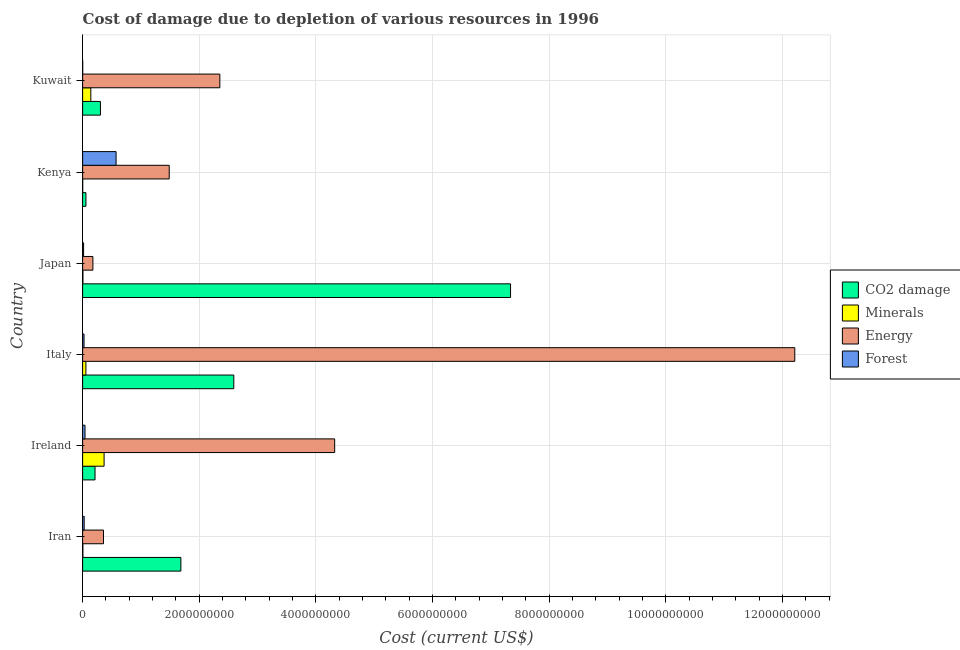How many different coloured bars are there?
Your answer should be compact. 4. How many groups of bars are there?
Offer a very short reply. 6. Are the number of bars per tick equal to the number of legend labels?
Keep it short and to the point. Yes. Are the number of bars on each tick of the Y-axis equal?
Give a very brief answer. Yes. How many bars are there on the 5th tick from the bottom?
Provide a succinct answer. 4. What is the label of the 2nd group of bars from the top?
Your response must be concise. Kenya. In how many cases, is the number of bars for a given country not equal to the number of legend labels?
Offer a very short reply. 0. What is the cost of damage due to depletion of minerals in Italy?
Provide a short and direct response. 5.60e+07. Across all countries, what is the maximum cost of damage due to depletion of forests?
Offer a very short reply. 5.74e+08. Across all countries, what is the minimum cost of damage due to depletion of energy?
Keep it short and to the point. 1.76e+08. In which country was the cost of damage due to depletion of minerals minimum?
Provide a short and direct response. Kenya. What is the total cost of damage due to depletion of forests in the graph?
Ensure brevity in your answer.  6.82e+08. What is the difference between the cost of damage due to depletion of energy in Iran and that in Ireland?
Your answer should be very brief. -3.96e+09. What is the difference between the cost of damage due to depletion of coal in Iran and the cost of damage due to depletion of minerals in Ireland?
Provide a short and direct response. 1.32e+09. What is the average cost of damage due to depletion of energy per country?
Your response must be concise. 3.48e+09. What is the difference between the cost of damage due to depletion of minerals and cost of damage due to depletion of energy in Japan?
Your response must be concise. -1.71e+08. What is the ratio of the cost of damage due to depletion of minerals in Japan to that in Kenya?
Provide a succinct answer. 3.73. Is the cost of damage due to depletion of forests in Ireland less than that in Japan?
Make the answer very short. No. What is the difference between the highest and the second highest cost of damage due to depletion of forests?
Ensure brevity in your answer.  5.33e+08. What is the difference between the highest and the lowest cost of damage due to depletion of energy?
Make the answer very short. 1.20e+1. Is it the case that in every country, the sum of the cost of damage due to depletion of coal and cost of damage due to depletion of forests is greater than the sum of cost of damage due to depletion of minerals and cost of damage due to depletion of energy?
Give a very brief answer. No. What does the 1st bar from the top in Kenya represents?
Make the answer very short. Forest. What does the 4th bar from the bottom in Kenya represents?
Provide a succinct answer. Forest. Is it the case that in every country, the sum of the cost of damage due to depletion of coal and cost of damage due to depletion of minerals is greater than the cost of damage due to depletion of energy?
Give a very brief answer. No. How many bars are there?
Offer a terse response. 24. What is the difference between two consecutive major ticks on the X-axis?
Offer a very short reply. 2.00e+09. Does the graph contain any zero values?
Keep it short and to the point. No. Where does the legend appear in the graph?
Ensure brevity in your answer.  Center right. How are the legend labels stacked?
Your answer should be compact. Vertical. What is the title of the graph?
Your response must be concise. Cost of damage due to depletion of various resources in 1996 . Does "Primary" appear as one of the legend labels in the graph?
Your answer should be compact. No. What is the label or title of the X-axis?
Your answer should be compact. Cost (current US$). What is the label or title of the Y-axis?
Provide a succinct answer. Country. What is the Cost (current US$) in CO2 damage in Iran?
Your response must be concise. 1.68e+09. What is the Cost (current US$) in Minerals in Iran?
Ensure brevity in your answer.  3.78e+06. What is the Cost (current US$) in Energy in Iran?
Provide a succinct answer. 3.58e+08. What is the Cost (current US$) of Forest in Iran?
Give a very brief answer. 2.68e+07. What is the Cost (current US$) in CO2 damage in Ireland?
Ensure brevity in your answer.  2.13e+08. What is the Cost (current US$) in Minerals in Ireland?
Your response must be concise. 3.68e+08. What is the Cost (current US$) in Energy in Ireland?
Your answer should be very brief. 4.32e+09. What is the Cost (current US$) of Forest in Ireland?
Provide a succinct answer. 4.08e+07. What is the Cost (current US$) in CO2 damage in Italy?
Your answer should be compact. 2.59e+09. What is the Cost (current US$) in Minerals in Italy?
Your answer should be very brief. 5.60e+07. What is the Cost (current US$) of Energy in Italy?
Ensure brevity in your answer.  1.22e+1. What is the Cost (current US$) in Forest in Italy?
Provide a short and direct response. 2.40e+07. What is the Cost (current US$) of CO2 damage in Japan?
Your answer should be compact. 7.34e+09. What is the Cost (current US$) in Minerals in Japan?
Your answer should be very brief. 4.88e+06. What is the Cost (current US$) in Energy in Japan?
Keep it short and to the point. 1.76e+08. What is the Cost (current US$) of Forest in Japan?
Provide a short and direct response. 1.65e+07. What is the Cost (current US$) of CO2 damage in Kenya?
Your response must be concise. 5.68e+07. What is the Cost (current US$) of Minerals in Kenya?
Provide a short and direct response. 1.31e+06. What is the Cost (current US$) in Energy in Kenya?
Your answer should be very brief. 1.49e+09. What is the Cost (current US$) in Forest in Kenya?
Your answer should be very brief. 5.74e+08. What is the Cost (current US$) of CO2 damage in Kuwait?
Your answer should be very brief. 3.05e+08. What is the Cost (current US$) of Minerals in Kuwait?
Provide a succinct answer. 1.40e+08. What is the Cost (current US$) of Energy in Kuwait?
Your answer should be compact. 2.35e+09. What is the Cost (current US$) in Forest in Kuwait?
Make the answer very short. 6.19e+05. Across all countries, what is the maximum Cost (current US$) in CO2 damage?
Your answer should be compact. 7.34e+09. Across all countries, what is the maximum Cost (current US$) of Minerals?
Offer a terse response. 3.68e+08. Across all countries, what is the maximum Cost (current US$) of Energy?
Provide a succinct answer. 1.22e+1. Across all countries, what is the maximum Cost (current US$) of Forest?
Provide a short and direct response. 5.74e+08. Across all countries, what is the minimum Cost (current US$) in CO2 damage?
Give a very brief answer. 5.68e+07. Across all countries, what is the minimum Cost (current US$) of Minerals?
Ensure brevity in your answer.  1.31e+06. Across all countries, what is the minimum Cost (current US$) in Energy?
Ensure brevity in your answer.  1.76e+08. Across all countries, what is the minimum Cost (current US$) of Forest?
Provide a succinct answer. 6.19e+05. What is the total Cost (current US$) in CO2 damage in the graph?
Provide a succinct answer. 1.22e+1. What is the total Cost (current US$) in Minerals in the graph?
Offer a terse response. 5.74e+08. What is the total Cost (current US$) of Energy in the graph?
Your answer should be very brief. 2.09e+1. What is the total Cost (current US$) of Forest in the graph?
Provide a succinct answer. 6.82e+08. What is the difference between the Cost (current US$) of CO2 damage in Iran and that in Ireland?
Keep it short and to the point. 1.47e+09. What is the difference between the Cost (current US$) of Minerals in Iran and that in Ireland?
Offer a very short reply. -3.64e+08. What is the difference between the Cost (current US$) of Energy in Iran and that in Ireland?
Give a very brief answer. -3.96e+09. What is the difference between the Cost (current US$) in Forest in Iran and that in Ireland?
Ensure brevity in your answer.  -1.41e+07. What is the difference between the Cost (current US$) of CO2 damage in Iran and that in Italy?
Give a very brief answer. -9.08e+08. What is the difference between the Cost (current US$) in Minerals in Iran and that in Italy?
Give a very brief answer. -5.22e+07. What is the difference between the Cost (current US$) in Energy in Iran and that in Italy?
Ensure brevity in your answer.  -1.19e+1. What is the difference between the Cost (current US$) of Forest in Iran and that in Italy?
Your answer should be compact. 2.76e+06. What is the difference between the Cost (current US$) of CO2 damage in Iran and that in Japan?
Offer a very short reply. -5.65e+09. What is the difference between the Cost (current US$) of Minerals in Iran and that in Japan?
Your response must be concise. -1.10e+06. What is the difference between the Cost (current US$) of Energy in Iran and that in Japan?
Keep it short and to the point. 1.82e+08. What is the difference between the Cost (current US$) of Forest in Iran and that in Japan?
Your answer should be very brief. 1.03e+07. What is the difference between the Cost (current US$) in CO2 damage in Iran and that in Kenya?
Give a very brief answer. 1.63e+09. What is the difference between the Cost (current US$) in Minerals in Iran and that in Kenya?
Offer a very short reply. 2.47e+06. What is the difference between the Cost (current US$) of Energy in Iran and that in Kenya?
Ensure brevity in your answer.  -1.13e+09. What is the difference between the Cost (current US$) in Forest in Iran and that in Kenya?
Keep it short and to the point. -5.47e+08. What is the difference between the Cost (current US$) in CO2 damage in Iran and that in Kuwait?
Provide a succinct answer. 1.38e+09. What is the difference between the Cost (current US$) of Minerals in Iran and that in Kuwait?
Provide a short and direct response. -1.36e+08. What is the difference between the Cost (current US$) of Energy in Iran and that in Kuwait?
Provide a short and direct response. -2.00e+09. What is the difference between the Cost (current US$) of Forest in Iran and that in Kuwait?
Ensure brevity in your answer.  2.61e+07. What is the difference between the Cost (current US$) of CO2 damage in Ireland and that in Italy?
Keep it short and to the point. -2.38e+09. What is the difference between the Cost (current US$) in Minerals in Ireland and that in Italy?
Give a very brief answer. 3.12e+08. What is the difference between the Cost (current US$) in Energy in Ireland and that in Italy?
Give a very brief answer. -7.89e+09. What is the difference between the Cost (current US$) in Forest in Ireland and that in Italy?
Offer a very short reply. 1.68e+07. What is the difference between the Cost (current US$) of CO2 damage in Ireland and that in Japan?
Provide a succinct answer. -7.13e+09. What is the difference between the Cost (current US$) in Minerals in Ireland and that in Japan?
Offer a terse response. 3.63e+08. What is the difference between the Cost (current US$) in Energy in Ireland and that in Japan?
Offer a very short reply. 4.15e+09. What is the difference between the Cost (current US$) in Forest in Ireland and that in Japan?
Your response must be concise. 2.43e+07. What is the difference between the Cost (current US$) in CO2 damage in Ireland and that in Kenya?
Provide a succinct answer. 1.56e+08. What is the difference between the Cost (current US$) of Minerals in Ireland and that in Kenya?
Your response must be concise. 3.67e+08. What is the difference between the Cost (current US$) of Energy in Ireland and that in Kenya?
Provide a short and direct response. 2.84e+09. What is the difference between the Cost (current US$) in Forest in Ireland and that in Kenya?
Offer a very short reply. -5.33e+08. What is the difference between the Cost (current US$) in CO2 damage in Ireland and that in Kuwait?
Your answer should be very brief. -9.28e+07. What is the difference between the Cost (current US$) in Minerals in Ireland and that in Kuwait?
Offer a very short reply. 2.28e+08. What is the difference between the Cost (current US$) in Energy in Ireland and that in Kuwait?
Your answer should be very brief. 1.97e+09. What is the difference between the Cost (current US$) in Forest in Ireland and that in Kuwait?
Offer a very short reply. 4.02e+07. What is the difference between the Cost (current US$) of CO2 damage in Italy and that in Japan?
Your response must be concise. -4.75e+09. What is the difference between the Cost (current US$) in Minerals in Italy and that in Japan?
Your answer should be very brief. 5.11e+07. What is the difference between the Cost (current US$) in Energy in Italy and that in Japan?
Provide a short and direct response. 1.20e+1. What is the difference between the Cost (current US$) of Forest in Italy and that in Japan?
Offer a very short reply. 7.50e+06. What is the difference between the Cost (current US$) of CO2 damage in Italy and that in Kenya?
Offer a terse response. 2.54e+09. What is the difference between the Cost (current US$) in Minerals in Italy and that in Kenya?
Offer a terse response. 5.47e+07. What is the difference between the Cost (current US$) in Energy in Italy and that in Kenya?
Your answer should be very brief. 1.07e+1. What is the difference between the Cost (current US$) of Forest in Italy and that in Kenya?
Your answer should be very brief. -5.50e+08. What is the difference between the Cost (current US$) of CO2 damage in Italy and that in Kuwait?
Provide a short and direct response. 2.29e+09. What is the difference between the Cost (current US$) in Minerals in Italy and that in Kuwait?
Your answer should be compact. -8.43e+07. What is the difference between the Cost (current US$) in Energy in Italy and that in Kuwait?
Make the answer very short. 9.86e+09. What is the difference between the Cost (current US$) in Forest in Italy and that in Kuwait?
Keep it short and to the point. 2.34e+07. What is the difference between the Cost (current US$) in CO2 damage in Japan and that in Kenya?
Provide a short and direct response. 7.28e+09. What is the difference between the Cost (current US$) in Minerals in Japan and that in Kenya?
Provide a succinct answer. 3.57e+06. What is the difference between the Cost (current US$) of Energy in Japan and that in Kenya?
Your response must be concise. -1.31e+09. What is the difference between the Cost (current US$) of Forest in Japan and that in Kenya?
Give a very brief answer. -5.57e+08. What is the difference between the Cost (current US$) of CO2 damage in Japan and that in Kuwait?
Provide a succinct answer. 7.03e+09. What is the difference between the Cost (current US$) of Minerals in Japan and that in Kuwait?
Keep it short and to the point. -1.35e+08. What is the difference between the Cost (current US$) of Energy in Japan and that in Kuwait?
Your response must be concise. -2.18e+09. What is the difference between the Cost (current US$) in Forest in Japan and that in Kuwait?
Provide a succinct answer. 1.59e+07. What is the difference between the Cost (current US$) in CO2 damage in Kenya and that in Kuwait?
Give a very brief answer. -2.49e+08. What is the difference between the Cost (current US$) of Minerals in Kenya and that in Kuwait?
Offer a very short reply. -1.39e+08. What is the difference between the Cost (current US$) of Energy in Kenya and that in Kuwait?
Provide a succinct answer. -8.68e+08. What is the difference between the Cost (current US$) of Forest in Kenya and that in Kuwait?
Give a very brief answer. 5.73e+08. What is the difference between the Cost (current US$) of CO2 damage in Iran and the Cost (current US$) of Minerals in Ireland?
Your answer should be very brief. 1.32e+09. What is the difference between the Cost (current US$) in CO2 damage in Iran and the Cost (current US$) in Energy in Ireland?
Your response must be concise. -2.64e+09. What is the difference between the Cost (current US$) in CO2 damage in Iran and the Cost (current US$) in Forest in Ireland?
Your response must be concise. 1.64e+09. What is the difference between the Cost (current US$) of Minerals in Iran and the Cost (current US$) of Energy in Ireland?
Provide a succinct answer. -4.32e+09. What is the difference between the Cost (current US$) in Minerals in Iran and the Cost (current US$) in Forest in Ireland?
Offer a terse response. -3.70e+07. What is the difference between the Cost (current US$) in Energy in Iran and the Cost (current US$) in Forest in Ireland?
Offer a very short reply. 3.17e+08. What is the difference between the Cost (current US$) of CO2 damage in Iran and the Cost (current US$) of Minerals in Italy?
Offer a very short reply. 1.63e+09. What is the difference between the Cost (current US$) in CO2 damage in Iran and the Cost (current US$) in Energy in Italy?
Offer a terse response. -1.05e+1. What is the difference between the Cost (current US$) of CO2 damage in Iran and the Cost (current US$) of Forest in Italy?
Your answer should be compact. 1.66e+09. What is the difference between the Cost (current US$) in Minerals in Iran and the Cost (current US$) in Energy in Italy?
Ensure brevity in your answer.  -1.22e+1. What is the difference between the Cost (current US$) in Minerals in Iran and the Cost (current US$) in Forest in Italy?
Ensure brevity in your answer.  -2.02e+07. What is the difference between the Cost (current US$) in Energy in Iran and the Cost (current US$) in Forest in Italy?
Your answer should be very brief. 3.34e+08. What is the difference between the Cost (current US$) of CO2 damage in Iran and the Cost (current US$) of Minerals in Japan?
Provide a succinct answer. 1.68e+09. What is the difference between the Cost (current US$) in CO2 damage in Iran and the Cost (current US$) in Energy in Japan?
Ensure brevity in your answer.  1.51e+09. What is the difference between the Cost (current US$) in CO2 damage in Iran and the Cost (current US$) in Forest in Japan?
Provide a succinct answer. 1.67e+09. What is the difference between the Cost (current US$) of Minerals in Iran and the Cost (current US$) of Energy in Japan?
Make the answer very short. -1.72e+08. What is the difference between the Cost (current US$) of Minerals in Iran and the Cost (current US$) of Forest in Japan?
Give a very brief answer. -1.27e+07. What is the difference between the Cost (current US$) in Energy in Iran and the Cost (current US$) in Forest in Japan?
Your response must be concise. 3.41e+08. What is the difference between the Cost (current US$) in CO2 damage in Iran and the Cost (current US$) in Minerals in Kenya?
Make the answer very short. 1.68e+09. What is the difference between the Cost (current US$) in CO2 damage in Iran and the Cost (current US$) in Energy in Kenya?
Your response must be concise. 2.00e+08. What is the difference between the Cost (current US$) in CO2 damage in Iran and the Cost (current US$) in Forest in Kenya?
Give a very brief answer. 1.11e+09. What is the difference between the Cost (current US$) in Minerals in Iran and the Cost (current US$) in Energy in Kenya?
Provide a succinct answer. -1.48e+09. What is the difference between the Cost (current US$) in Minerals in Iran and the Cost (current US$) in Forest in Kenya?
Ensure brevity in your answer.  -5.70e+08. What is the difference between the Cost (current US$) of Energy in Iran and the Cost (current US$) of Forest in Kenya?
Ensure brevity in your answer.  -2.16e+08. What is the difference between the Cost (current US$) of CO2 damage in Iran and the Cost (current US$) of Minerals in Kuwait?
Your answer should be very brief. 1.54e+09. What is the difference between the Cost (current US$) in CO2 damage in Iran and the Cost (current US$) in Energy in Kuwait?
Your answer should be very brief. -6.68e+08. What is the difference between the Cost (current US$) in CO2 damage in Iran and the Cost (current US$) in Forest in Kuwait?
Your answer should be compact. 1.68e+09. What is the difference between the Cost (current US$) of Minerals in Iran and the Cost (current US$) of Energy in Kuwait?
Offer a terse response. -2.35e+09. What is the difference between the Cost (current US$) in Minerals in Iran and the Cost (current US$) in Forest in Kuwait?
Offer a very short reply. 3.16e+06. What is the difference between the Cost (current US$) in Energy in Iran and the Cost (current US$) in Forest in Kuwait?
Your answer should be very brief. 3.57e+08. What is the difference between the Cost (current US$) in CO2 damage in Ireland and the Cost (current US$) in Minerals in Italy?
Make the answer very short. 1.57e+08. What is the difference between the Cost (current US$) in CO2 damage in Ireland and the Cost (current US$) in Energy in Italy?
Make the answer very short. -1.20e+1. What is the difference between the Cost (current US$) of CO2 damage in Ireland and the Cost (current US$) of Forest in Italy?
Offer a very short reply. 1.89e+08. What is the difference between the Cost (current US$) in Minerals in Ireland and the Cost (current US$) in Energy in Italy?
Ensure brevity in your answer.  -1.18e+1. What is the difference between the Cost (current US$) in Minerals in Ireland and the Cost (current US$) in Forest in Italy?
Give a very brief answer. 3.44e+08. What is the difference between the Cost (current US$) in Energy in Ireland and the Cost (current US$) in Forest in Italy?
Provide a short and direct response. 4.30e+09. What is the difference between the Cost (current US$) of CO2 damage in Ireland and the Cost (current US$) of Minerals in Japan?
Your response must be concise. 2.08e+08. What is the difference between the Cost (current US$) of CO2 damage in Ireland and the Cost (current US$) of Energy in Japan?
Provide a short and direct response. 3.65e+07. What is the difference between the Cost (current US$) in CO2 damage in Ireland and the Cost (current US$) in Forest in Japan?
Make the answer very short. 1.96e+08. What is the difference between the Cost (current US$) in Minerals in Ireland and the Cost (current US$) in Energy in Japan?
Offer a very short reply. 1.92e+08. What is the difference between the Cost (current US$) in Minerals in Ireland and the Cost (current US$) in Forest in Japan?
Your answer should be compact. 3.52e+08. What is the difference between the Cost (current US$) in Energy in Ireland and the Cost (current US$) in Forest in Japan?
Your response must be concise. 4.31e+09. What is the difference between the Cost (current US$) of CO2 damage in Ireland and the Cost (current US$) of Minerals in Kenya?
Your answer should be compact. 2.11e+08. What is the difference between the Cost (current US$) in CO2 damage in Ireland and the Cost (current US$) in Energy in Kenya?
Offer a very short reply. -1.27e+09. What is the difference between the Cost (current US$) of CO2 damage in Ireland and the Cost (current US$) of Forest in Kenya?
Give a very brief answer. -3.61e+08. What is the difference between the Cost (current US$) of Minerals in Ireland and the Cost (current US$) of Energy in Kenya?
Your answer should be compact. -1.12e+09. What is the difference between the Cost (current US$) in Minerals in Ireland and the Cost (current US$) in Forest in Kenya?
Make the answer very short. -2.06e+08. What is the difference between the Cost (current US$) of Energy in Ireland and the Cost (current US$) of Forest in Kenya?
Offer a terse response. 3.75e+09. What is the difference between the Cost (current US$) in CO2 damage in Ireland and the Cost (current US$) in Minerals in Kuwait?
Offer a terse response. 7.23e+07. What is the difference between the Cost (current US$) in CO2 damage in Ireland and the Cost (current US$) in Energy in Kuwait?
Ensure brevity in your answer.  -2.14e+09. What is the difference between the Cost (current US$) of CO2 damage in Ireland and the Cost (current US$) of Forest in Kuwait?
Keep it short and to the point. 2.12e+08. What is the difference between the Cost (current US$) in Minerals in Ireland and the Cost (current US$) in Energy in Kuwait?
Provide a succinct answer. -1.98e+09. What is the difference between the Cost (current US$) in Minerals in Ireland and the Cost (current US$) in Forest in Kuwait?
Provide a short and direct response. 3.68e+08. What is the difference between the Cost (current US$) in Energy in Ireland and the Cost (current US$) in Forest in Kuwait?
Ensure brevity in your answer.  4.32e+09. What is the difference between the Cost (current US$) of CO2 damage in Italy and the Cost (current US$) of Minerals in Japan?
Provide a succinct answer. 2.59e+09. What is the difference between the Cost (current US$) in CO2 damage in Italy and the Cost (current US$) in Energy in Japan?
Make the answer very short. 2.42e+09. What is the difference between the Cost (current US$) of CO2 damage in Italy and the Cost (current US$) of Forest in Japan?
Make the answer very short. 2.58e+09. What is the difference between the Cost (current US$) in Minerals in Italy and the Cost (current US$) in Energy in Japan?
Provide a short and direct response. -1.20e+08. What is the difference between the Cost (current US$) of Minerals in Italy and the Cost (current US$) of Forest in Japan?
Your answer should be compact. 3.95e+07. What is the difference between the Cost (current US$) of Energy in Italy and the Cost (current US$) of Forest in Japan?
Provide a short and direct response. 1.22e+1. What is the difference between the Cost (current US$) of CO2 damage in Italy and the Cost (current US$) of Minerals in Kenya?
Your answer should be compact. 2.59e+09. What is the difference between the Cost (current US$) in CO2 damage in Italy and the Cost (current US$) in Energy in Kenya?
Offer a very short reply. 1.11e+09. What is the difference between the Cost (current US$) of CO2 damage in Italy and the Cost (current US$) of Forest in Kenya?
Your answer should be very brief. 2.02e+09. What is the difference between the Cost (current US$) in Minerals in Italy and the Cost (current US$) in Energy in Kenya?
Keep it short and to the point. -1.43e+09. What is the difference between the Cost (current US$) of Minerals in Italy and the Cost (current US$) of Forest in Kenya?
Keep it short and to the point. -5.18e+08. What is the difference between the Cost (current US$) of Energy in Italy and the Cost (current US$) of Forest in Kenya?
Keep it short and to the point. 1.16e+1. What is the difference between the Cost (current US$) in CO2 damage in Italy and the Cost (current US$) in Minerals in Kuwait?
Offer a very short reply. 2.45e+09. What is the difference between the Cost (current US$) in CO2 damage in Italy and the Cost (current US$) in Energy in Kuwait?
Offer a very short reply. 2.39e+08. What is the difference between the Cost (current US$) of CO2 damage in Italy and the Cost (current US$) of Forest in Kuwait?
Keep it short and to the point. 2.59e+09. What is the difference between the Cost (current US$) in Minerals in Italy and the Cost (current US$) in Energy in Kuwait?
Provide a short and direct response. -2.30e+09. What is the difference between the Cost (current US$) in Minerals in Italy and the Cost (current US$) in Forest in Kuwait?
Offer a very short reply. 5.54e+07. What is the difference between the Cost (current US$) of Energy in Italy and the Cost (current US$) of Forest in Kuwait?
Your answer should be compact. 1.22e+1. What is the difference between the Cost (current US$) in CO2 damage in Japan and the Cost (current US$) in Minerals in Kenya?
Keep it short and to the point. 7.34e+09. What is the difference between the Cost (current US$) in CO2 damage in Japan and the Cost (current US$) in Energy in Kenya?
Keep it short and to the point. 5.85e+09. What is the difference between the Cost (current US$) of CO2 damage in Japan and the Cost (current US$) of Forest in Kenya?
Your answer should be compact. 6.76e+09. What is the difference between the Cost (current US$) in Minerals in Japan and the Cost (current US$) in Energy in Kenya?
Give a very brief answer. -1.48e+09. What is the difference between the Cost (current US$) of Minerals in Japan and the Cost (current US$) of Forest in Kenya?
Provide a succinct answer. -5.69e+08. What is the difference between the Cost (current US$) of Energy in Japan and the Cost (current US$) of Forest in Kenya?
Keep it short and to the point. -3.98e+08. What is the difference between the Cost (current US$) in CO2 damage in Japan and the Cost (current US$) in Minerals in Kuwait?
Provide a succinct answer. 7.20e+09. What is the difference between the Cost (current US$) of CO2 damage in Japan and the Cost (current US$) of Energy in Kuwait?
Your answer should be very brief. 4.99e+09. What is the difference between the Cost (current US$) of CO2 damage in Japan and the Cost (current US$) of Forest in Kuwait?
Provide a short and direct response. 7.34e+09. What is the difference between the Cost (current US$) in Minerals in Japan and the Cost (current US$) in Energy in Kuwait?
Give a very brief answer. -2.35e+09. What is the difference between the Cost (current US$) in Minerals in Japan and the Cost (current US$) in Forest in Kuwait?
Keep it short and to the point. 4.26e+06. What is the difference between the Cost (current US$) in Energy in Japan and the Cost (current US$) in Forest in Kuwait?
Offer a terse response. 1.75e+08. What is the difference between the Cost (current US$) in CO2 damage in Kenya and the Cost (current US$) in Minerals in Kuwait?
Make the answer very short. -8.35e+07. What is the difference between the Cost (current US$) in CO2 damage in Kenya and the Cost (current US$) in Energy in Kuwait?
Your response must be concise. -2.30e+09. What is the difference between the Cost (current US$) of CO2 damage in Kenya and the Cost (current US$) of Forest in Kuwait?
Offer a very short reply. 5.62e+07. What is the difference between the Cost (current US$) in Minerals in Kenya and the Cost (current US$) in Energy in Kuwait?
Your answer should be very brief. -2.35e+09. What is the difference between the Cost (current US$) of Minerals in Kenya and the Cost (current US$) of Forest in Kuwait?
Provide a short and direct response. 6.90e+05. What is the difference between the Cost (current US$) of Energy in Kenya and the Cost (current US$) of Forest in Kuwait?
Ensure brevity in your answer.  1.48e+09. What is the average Cost (current US$) in CO2 damage per country?
Keep it short and to the point. 2.03e+09. What is the average Cost (current US$) of Minerals per country?
Provide a succinct answer. 9.57e+07. What is the average Cost (current US$) of Energy per country?
Your answer should be compact. 3.48e+09. What is the average Cost (current US$) in Forest per country?
Make the answer very short. 1.14e+08. What is the difference between the Cost (current US$) in CO2 damage and Cost (current US$) in Minerals in Iran?
Offer a terse response. 1.68e+09. What is the difference between the Cost (current US$) in CO2 damage and Cost (current US$) in Energy in Iran?
Provide a succinct answer. 1.33e+09. What is the difference between the Cost (current US$) in CO2 damage and Cost (current US$) in Forest in Iran?
Keep it short and to the point. 1.66e+09. What is the difference between the Cost (current US$) in Minerals and Cost (current US$) in Energy in Iran?
Offer a terse response. -3.54e+08. What is the difference between the Cost (current US$) of Minerals and Cost (current US$) of Forest in Iran?
Make the answer very short. -2.30e+07. What is the difference between the Cost (current US$) of Energy and Cost (current US$) of Forest in Iran?
Make the answer very short. 3.31e+08. What is the difference between the Cost (current US$) of CO2 damage and Cost (current US$) of Minerals in Ireland?
Offer a very short reply. -1.56e+08. What is the difference between the Cost (current US$) in CO2 damage and Cost (current US$) in Energy in Ireland?
Provide a short and direct response. -4.11e+09. What is the difference between the Cost (current US$) in CO2 damage and Cost (current US$) in Forest in Ireland?
Offer a very short reply. 1.72e+08. What is the difference between the Cost (current US$) of Minerals and Cost (current US$) of Energy in Ireland?
Offer a terse response. -3.95e+09. What is the difference between the Cost (current US$) in Minerals and Cost (current US$) in Forest in Ireland?
Make the answer very short. 3.27e+08. What is the difference between the Cost (current US$) in Energy and Cost (current US$) in Forest in Ireland?
Give a very brief answer. 4.28e+09. What is the difference between the Cost (current US$) in CO2 damage and Cost (current US$) in Minerals in Italy?
Give a very brief answer. 2.54e+09. What is the difference between the Cost (current US$) of CO2 damage and Cost (current US$) of Energy in Italy?
Your response must be concise. -9.62e+09. What is the difference between the Cost (current US$) in CO2 damage and Cost (current US$) in Forest in Italy?
Your answer should be very brief. 2.57e+09. What is the difference between the Cost (current US$) of Minerals and Cost (current US$) of Energy in Italy?
Make the answer very short. -1.22e+1. What is the difference between the Cost (current US$) of Minerals and Cost (current US$) of Forest in Italy?
Provide a succinct answer. 3.20e+07. What is the difference between the Cost (current US$) of Energy and Cost (current US$) of Forest in Italy?
Your response must be concise. 1.22e+1. What is the difference between the Cost (current US$) in CO2 damage and Cost (current US$) in Minerals in Japan?
Offer a very short reply. 7.33e+09. What is the difference between the Cost (current US$) in CO2 damage and Cost (current US$) in Energy in Japan?
Provide a short and direct response. 7.16e+09. What is the difference between the Cost (current US$) of CO2 damage and Cost (current US$) of Forest in Japan?
Ensure brevity in your answer.  7.32e+09. What is the difference between the Cost (current US$) in Minerals and Cost (current US$) in Energy in Japan?
Offer a terse response. -1.71e+08. What is the difference between the Cost (current US$) of Minerals and Cost (current US$) of Forest in Japan?
Provide a short and direct response. -1.16e+07. What is the difference between the Cost (current US$) in Energy and Cost (current US$) in Forest in Japan?
Provide a short and direct response. 1.60e+08. What is the difference between the Cost (current US$) of CO2 damage and Cost (current US$) of Minerals in Kenya?
Your answer should be compact. 5.55e+07. What is the difference between the Cost (current US$) of CO2 damage and Cost (current US$) of Energy in Kenya?
Offer a very short reply. -1.43e+09. What is the difference between the Cost (current US$) in CO2 damage and Cost (current US$) in Forest in Kenya?
Ensure brevity in your answer.  -5.17e+08. What is the difference between the Cost (current US$) in Minerals and Cost (current US$) in Energy in Kenya?
Provide a short and direct response. -1.48e+09. What is the difference between the Cost (current US$) in Minerals and Cost (current US$) in Forest in Kenya?
Your response must be concise. -5.72e+08. What is the difference between the Cost (current US$) in Energy and Cost (current US$) in Forest in Kenya?
Give a very brief answer. 9.11e+08. What is the difference between the Cost (current US$) of CO2 damage and Cost (current US$) of Minerals in Kuwait?
Make the answer very short. 1.65e+08. What is the difference between the Cost (current US$) of CO2 damage and Cost (current US$) of Energy in Kuwait?
Make the answer very short. -2.05e+09. What is the difference between the Cost (current US$) in CO2 damage and Cost (current US$) in Forest in Kuwait?
Give a very brief answer. 3.05e+08. What is the difference between the Cost (current US$) in Minerals and Cost (current US$) in Energy in Kuwait?
Make the answer very short. -2.21e+09. What is the difference between the Cost (current US$) of Minerals and Cost (current US$) of Forest in Kuwait?
Ensure brevity in your answer.  1.40e+08. What is the difference between the Cost (current US$) in Energy and Cost (current US$) in Forest in Kuwait?
Offer a terse response. 2.35e+09. What is the ratio of the Cost (current US$) in CO2 damage in Iran to that in Ireland?
Give a very brief answer. 7.93. What is the ratio of the Cost (current US$) of Minerals in Iran to that in Ireland?
Your answer should be compact. 0.01. What is the ratio of the Cost (current US$) of Energy in Iran to that in Ireland?
Offer a terse response. 0.08. What is the ratio of the Cost (current US$) of Forest in Iran to that in Ireland?
Make the answer very short. 0.66. What is the ratio of the Cost (current US$) in CO2 damage in Iran to that in Italy?
Make the answer very short. 0.65. What is the ratio of the Cost (current US$) of Minerals in Iran to that in Italy?
Offer a very short reply. 0.07. What is the ratio of the Cost (current US$) in Energy in Iran to that in Italy?
Provide a short and direct response. 0.03. What is the ratio of the Cost (current US$) of Forest in Iran to that in Italy?
Your response must be concise. 1.12. What is the ratio of the Cost (current US$) of CO2 damage in Iran to that in Japan?
Ensure brevity in your answer.  0.23. What is the ratio of the Cost (current US$) in Minerals in Iran to that in Japan?
Make the answer very short. 0.77. What is the ratio of the Cost (current US$) in Energy in Iran to that in Japan?
Keep it short and to the point. 2.03. What is the ratio of the Cost (current US$) in Forest in Iran to that in Japan?
Make the answer very short. 1.62. What is the ratio of the Cost (current US$) of CO2 damage in Iran to that in Kenya?
Your answer should be compact. 29.66. What is the ratio of the Cost (current US$) of Minerals in Iran to that in Kenya?
Offer a terse response. 2.88. What is the ratio of the Cost (current US$) in Energy in Iran to that in Kenya?
Offer a terse response. 0.24. What is the ratio of the Cost (current US$) in Forest in Iran to that in Kenya?
Give a very brief answer. 0.05. What is the ratio of the Cost (current US$) in CO2 damage in Iran to that in Kuwait?
Your response must be concise. 5.52. What is the ratio of the Cost (current US$) in Minerals in Iran to that in Kuwait?
Your response must be concise. 0.03. What is the ratio of the Cost (current US$) in Energy in Iran to that in Kuwait?
Offer a terse response. 0.15. What is the ratio of the Cost (current US$) of Forest in Iran to that in Kuwait?
Provide a succinct answer. 43.21. What is the ratio of the Cost (current US$) of CO2 damage in Ireland to that in Italy?
Your answer should be very brief. 0.08. What is the ratio of the Cost (current US$) of Minerals in Ireland to that in Italy?
Ensure brevity in your answer.  6.58. What is the ratio of the Cost (current US$) of Energy in Ireland to that in Italy?
Give a very brief answer. 0.35. What is the ratio of the Cost (current US$) in Forest in Ireland to that in Italy?
Provide a short and direct response. 1.7. What is the ratio of the Cost (current US$) in CO2 damage in Ireland to that in Japan?
Give a very brief answer. 0.03. What is the ratio of the Cost (current US$) in Minerals in Ireland to that in Japan?
Provide a short and direct response. 75.44. What is the ratio of the Cost (current US$) in Energy in Ireland to that in Japan?
Keep it short and to the point. 24.55. What is the ratio of the Cost (current US$) in Forest in Ireland to that in Japan?
Your answer should be very brief. 2.47. What is the ratio of the Cost (current US$) in CO2 damage in Ireland to that in Kenya?
Provide a succinct answer. 3.74. What is the ratio of the Cost (current US$) in Minerals in Ireland to that in Kenya?
Make the answer very short. 281.28. What is the ratio of the Cost (current US$) of Energy in Ireland to that in Kenya?
Your answer should be very brief. 2.91. What is the ratio of the Cost (current US$) of Forest in Ireland to that in Kenya?
Your answer should be very brief. 0.07. What is the ratio of the Cost (current US$) of CO2 damage in Ireland to that in Kuwait?
Make the answer very short. 0.7. What is the ratio of the Cost (current US$) in Minerals in Ireland to that in Kuwait?
Keep it short and to the point. 2.62. What is the ratio of the Cost (current US$) of Energy in Ireland to that in Kuwait?
Your answer should be compact. 1.84. What is the ratio of the Cost (current US$) of Forest in Ireland to that in Kuwait?
Your answer should be compact. 65.91. What is the ratio of the Cost (current US$) of CO2 damage in Italy to that in Japan?
Provide a succinct answer. 0.35. What is the ratio of the Cost (current US$) of Minerals in Italy to that in Japan?
Provide a short and direct response. 11.47. What is the ratio of the Cost (current US$) of Energy in Italy to that in Japan?
Make the answer very short. 69.38. What is the ratio of the Cost (current US$) in Forest in Italy to that in Japan?
Your answer should be compact. 1.45. What is the ratio of the Cost (current US$) of CO2 damage in Italy to that in Kenya?
Make the answer very short. 45.65. What is the ratio of the Cost (current US$) in Minerals in Italy to that in Kenya?
Provide a short and direct response. 42.78. What is the ratio of the Cost (current US$) of Energy in Italy to that in Kenya?
Your answer should be very brief. 8.22. What is the ratio of the Cost (current US$) in Forest in Italy to that in Kenya?
Your answer should be very brief. 0.04. What is the ratio of the Cost (current US$) of CO2 damage in Italy to that in Kuwait?
Your answer should be very brief. 8.49. What is the ratio of the Cost (current US$) of Minerals in Italy to that in Kuwait?
Keep it short and to the point. 0.4. What is the ratio of the Cost (current US$) in Energy in Italy to that in Kuwait?
Ensure brevity in your answer.  5.19. What is the ratio of the Cost (current US$) in Forest in Italy to that in Kuwait?
Provide a short and direct response. 38.75. What is the ratio of the Cost (current US$) of CO2 damage in Japan to that in Kenya?
Keep it short and to the point. 129.21. What is the ratio of the Cost (current US$) of Minerals in Japan to that in Kenya?
Your answer should be very brief. 3.73. What is the ratio of the Cost (current US$) in Energy in Japan to that in Kenya?
Your answer should be very brief. 0.12. What is the ratio of the Cost (current US$) of Forest in Japan to that in Kenya?
Ensure brevity in your answer.  0.03. What is the ratio of the Cost (current US$) of CO2 damage in Japan to that in Kuwait?
Ensure brevity in your answer.  24.03. What is the ratio of the Cost (current US$) in Minerals in Japan to that in Kuwait?
Offer a terse response. 0.03. What is the ratio of the Cost (current US$) of Energy in Japan to that in Kuwait?
Your answer should be compact. 0.07. What is the ratio of the Cost (current US$) of Forest in Japan to that in Kuwait?
Your answer should be very brief. 26.64. What is the ratio of the Cost (current US$) of CO2 damage in Kenya to that in Kuwait?
Keep it short and to the point. 0.19. What is the ratio of the Cost (current US$) in Minerals in Kenya to that in Kuwait?
Ensure brevity in your answer.  0.01. What is the ratio of the Cost (current US$) in Energy in Kenya to that in Kuwait?
Your answer should be compact. 0.63. What is the ratio of the Cost (current US$) of Forest in Kenya to that in Kuwait?
Give a very brief answer. 926.58. What is the difference between the highest and the second highest Cost (current US$) of CO2 damage?
Your answer should be compact. 4.75e+09. What is the difference between the highest and the second highest Cost (current US$) in Minerals?
Make the answer very short. 2.28e+08. What is the difference between the highest and the second highest Cost (current US$) of Energy?
Keep it short and to the point. 7.89e+09. What is the difference between the highest and the second highest Cost (current US$) of Forest?
Keep it short and to the point. 5.33e+08. What is the difference between the highest and the lowest Cost (current US$) of CO2 damage?
Ensure brevity in your answer.  7.28e+09. What is the difference between the highest and the lowest Cost (current US$) of Minerals?
Offer a terse response. 3.67e+08. What is the difference between the highest and the lowest Cost (current US$) in Energy?
Provide a short and direct response. 1.20e+1. What is the difference between the highest and the lowest Cost (current US$) of Forest?
Your answer should be compact. 5.73e+08. 